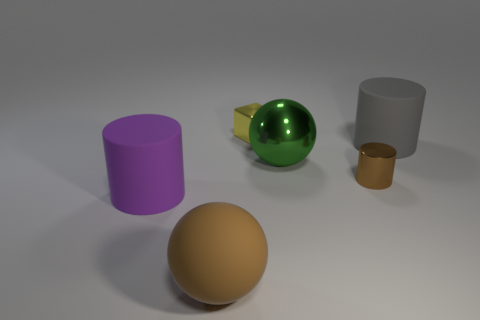Are the big brown object and the small block made of the same material?
Keep it short and to the point. No. Is the number of objects on the right side of the purple object the same as the number of small shiny objects right of the yellow object?
Offer a terse response. No. Is there a object to the right of the large cylinder right of the large purple matte object left of the large brown thing?
Offer a terse response. No. Does the gray rubber thing have the same size as the brown cylinder?
Your response must be concise. No. What is the color of the thing that is behind the large rubber cylinder on the right side of the large matte thing in front of the large purple thing?
Your answer should be very brief. Yellow. How many big shiny objects are the same color as the small metal cylinder?
Make the answer very short. 0. What number of tiny objects are either brown balls or blue matte spheres?
Provide a short and direct response. 0. Is there a yellow matte object of the same shape as the large green thing?
Provide a succinct answer. No. Does the gray rubber object have the same shape as the yellow object?
Provide a succinct answer. No. There is a matte thing to the right of the large ball that is on the left side of the green metallic object; what color is it?
Your answer should be very brief. Gray. 